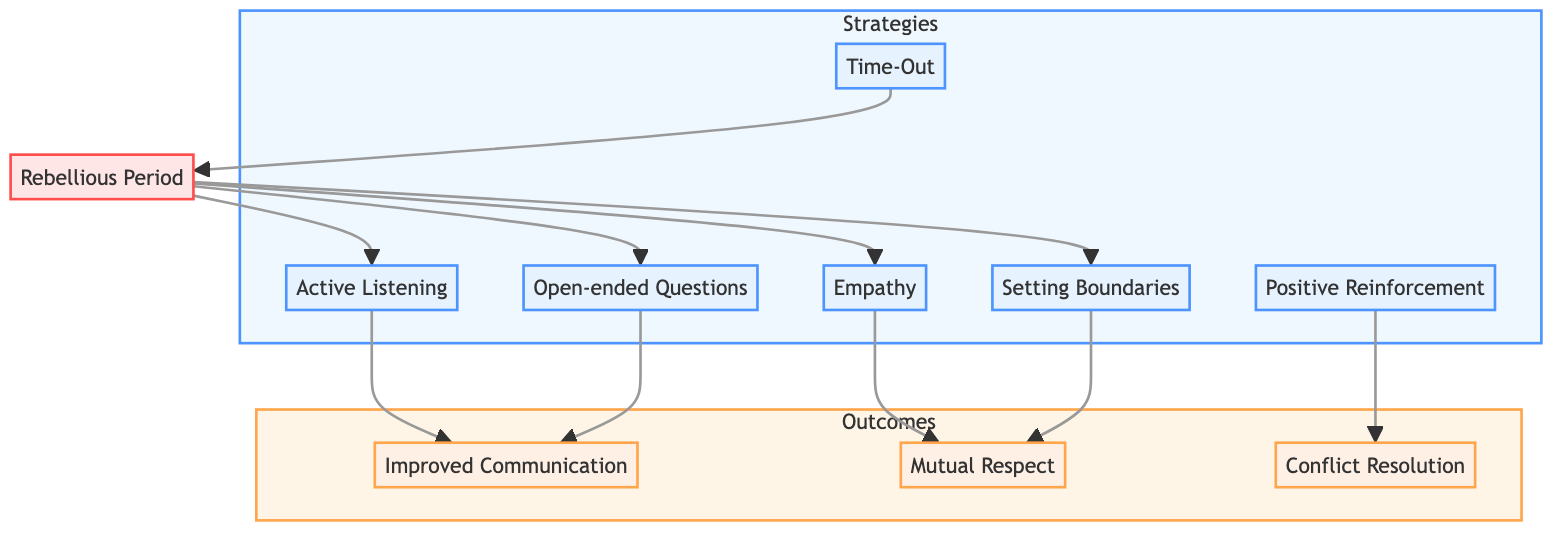What are the three outcomes listed in the diagram? The diagram shows three outcomes: Improved Communication, Mutual Respect, and Conflict Resolution. These outcomes can be identified by looking at the nodes connected to the strategies.
Answer: Improved Communication, Mutual Respect, Conflict Resolution How many strategies are displayed in the diagram? The diagram lists a total of six strategies. This can be confirmed by counting the nodes labeled as strategies, which are positioned on the left side of the diagram.
Answer: Six Which strategy leads to Mutual Respect? The diagram indicates that both Empathy and Setting Boundaries lead to Mutual Respect. To find this, one could follow the arrows from these strategies to their resulting outcome.
Answer: Empathy, Setting Boundaries What is the first strategy in the diagram? The first strategy is Active Listening, as it is the first node encountered on the left side of the diagram under the Strategies section.
Answer: Active Listening Which phase contains strategies that lead to Rebellious Period? The phase labeled Rebellious Period contains the strategies of Active Listening, Open-ended Questions, Empathy, and Setting Boundaries. By tracing back from the Rebellious Period node, these strategies can be seen as connected.
Answer: Active Listening, Open-ended Questions, Empathy, Setting Boundaries What is the relationship between Positive Reinforcement and Conflict Resolution? The relationship is direct: Positive Reinforcement is a strategy that leads to the outcome of Conflict Resolution, shown by the arrow connecting the two nodes.
Answer: Positive Reinforcement leads to Conflict Resolution 